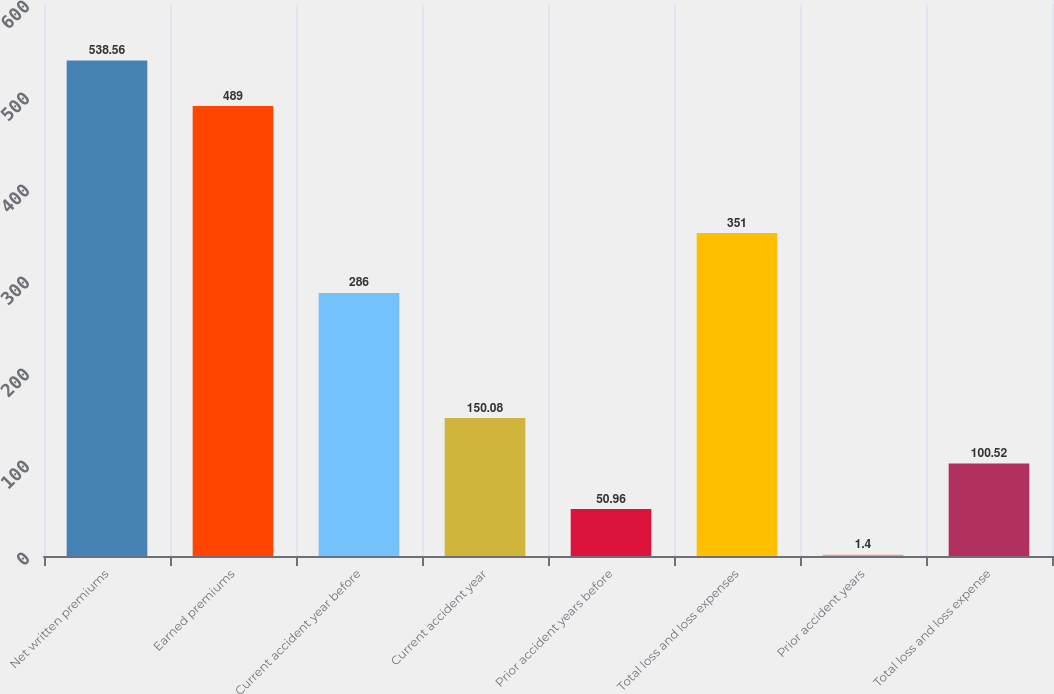Convert chart. <chart><loc_0><loc_0><loc_500><loc_500><bar_chart><fcel>Net written premiums<fcel>Earned premiums<fcel>Current accident year before<fcel>Current accident year<fcel>Prior accident years before<fcel>Total loss and loss expenses<fcel>Prior accident years<fcel>Total loss and loss expense<nl><fcel>538.56<fcel>489<fcel>286<fcel>150.08<fcel>50.96<fcel>351<fcel>1.4<fcel>100.52<nl></chart> 